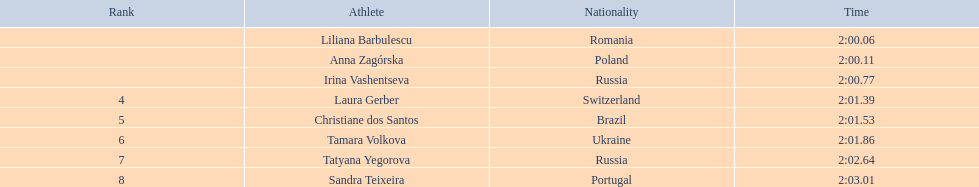What are the identities of the competitors? Liliana Barbulescu, Anna Zagórska, Irina Vashentseva, Laura Gerber, Christiane dos Santos, Tamara Volkova, Tatyana Yegorova, Sandra Teixeira. Who concluded the race the swiftest among the finalists? Liliana Barbulescu. 